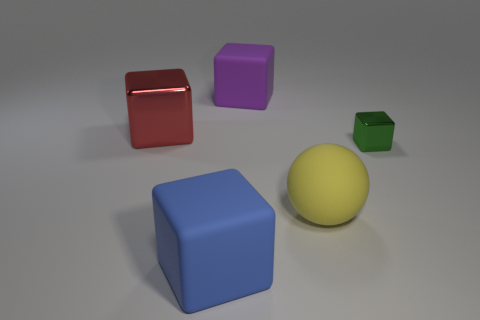What number of objects are either big blue blocks that are in front of the tiny metal object or small red cylinders?
Provide a succinct answer. 1. The red object has what size?
Offer a terse response. Large. There is a thing that is left of the big cube in front of the small green metal thing; what is its material?
Make the answer very short. Metal. There is a matte thing that is behind the ball; is it the same size as the tiny green cube?
Make the answer very short. No. Is there a big block of the same color as the tiny cube?
Provide a succinct answer. No. How many things are blocks that are behind the small metallic cube or cubes that are in front of the matte sphere?
Your answer should be very brief. 3. Are there fewer large spheres that are behind the rubber ball than metal cubes right of the purple matte thing?
Your answer should be compact. Yes. Are the blue block and the yellow thing made of the same material?
Your response must be concise. Yes. There is a object that is in front of the big red metallic object and behind the large yellow matte sphere; what is its size?
Your response must be concise. Small. What shape is the yellow rubber object that is the same size as the blue rubber object?
Make the answer very short. Sphere. 